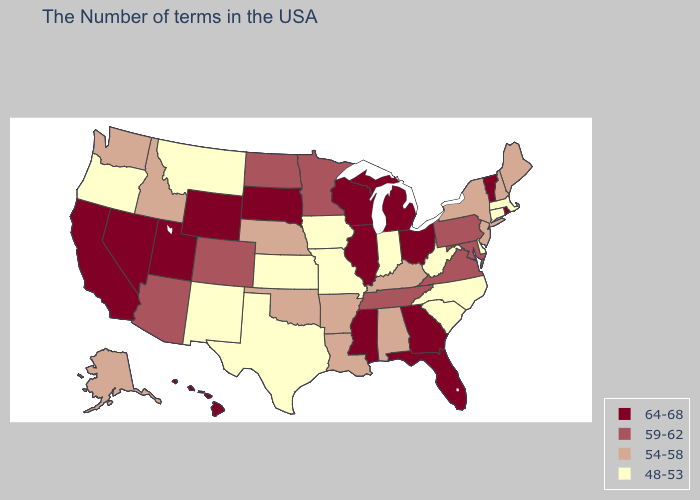Name the states that have a value in the range 64-68?
Concise answer only. Rhode Island, Vermont, Ohio, Florida, Georgia, Michigan, Wisconsin, Illinois, Mississippi, South Dakota, Wyoming, Utah, Nevada, California, Hawaii. Which states have the highest value in the USA?
Give a very brief answer. Rhode Island, Vermont, Ohio, Florida, Georgia, Michigan, Wisconsin, Illinois, Mississippi, South Dakota, Wyoming, Utah, Nevada, California, Hawaii. Name the states that have a value in the range 54-58?
Keep it brief. Maine, New Hampshire, New York, New Jersey, Kentucky, Alabama, Louisiana, Arkansas, Nebraska, Oklahoma, Idaho, Washington, Alaska. What is the highest value in the West ?
Be succinct. 64-68. Does North Carolina have a higher value than Iowa?
Answer briefly. No. Name the states that have a value in the range 48-53?
Concise answer only. Massachusetts, Connecticut, Delaware, North Carolina, South Carolina, West Virginia, Indiana, Missouri, Iowa, Kansas, Texas, New Mexico, Montana, Oregon. Name the states that have a value in the range 54-58?
Answer briefly. Maine, New Hampshire, New York, New Jersey, Kentucky, Alabama, Louisiana, Arkansas, Nebraska, Oklahoma, Idaho, Washington, Alaska. What is the value of Kansas?
Give a very brief answer. 48-53. Does Georgia have the lowest value in the USA?
Keep it brief. No. Name the states that have a value in the range 59-62?
Short answer required. Maryland, Pennsylvania, Virginia, Tennessee, Minnesota, North Dakota, Colorado, Arizona. How many symbols are there in the legend?
Answer briefly. 4. Does Washington have a higher value than Delaware?
Concise answer only. Yes. Does Delaware have the same value as Kansas?
Be succinct. Yes. Does Michigan have the highest value in the MidWest?
Be succinct. Yes. What is the highest value in the USA?
Short answer required. 64-68. 